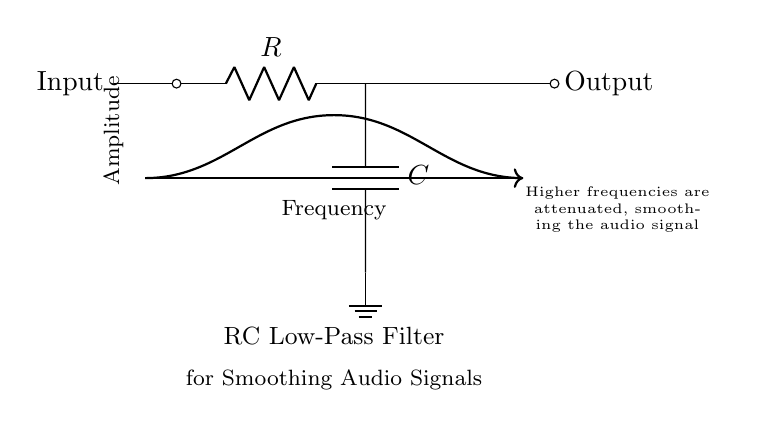What does "R" stand for in the circuit? "R" represents the resistor in the RC low-pass filter circuit, which limits the flow of current.
Answer: Resistor What does "C" represent in this diagram? "C" signifies the capacitor, which stores electrical energy temporarily in this circuit.
Answer: Capacitor What is the purpose of this circuit? This circuit serves to smooth audio signals by filtering out higher frequencies that may introduce noise.
Answer: Smoothing audio signals Which direction does the current flow? The current flows from the input, through the resistor, then to the capacitor, and finally to the output.
Answer: From input to output How does the frequency affect the output signal? Higher frequencies are attenuated by the capacitor, resulting in less amplitude in the output signal for those frequencies.
Answer: Higher frequencies are attenuated What happens to the audio signal at low frequencies? At low frequencies, the capacitor allows the signal to pass with minimal attenuation, hence the output maintains a strong signal level.
Answer: Minimal attenuation 